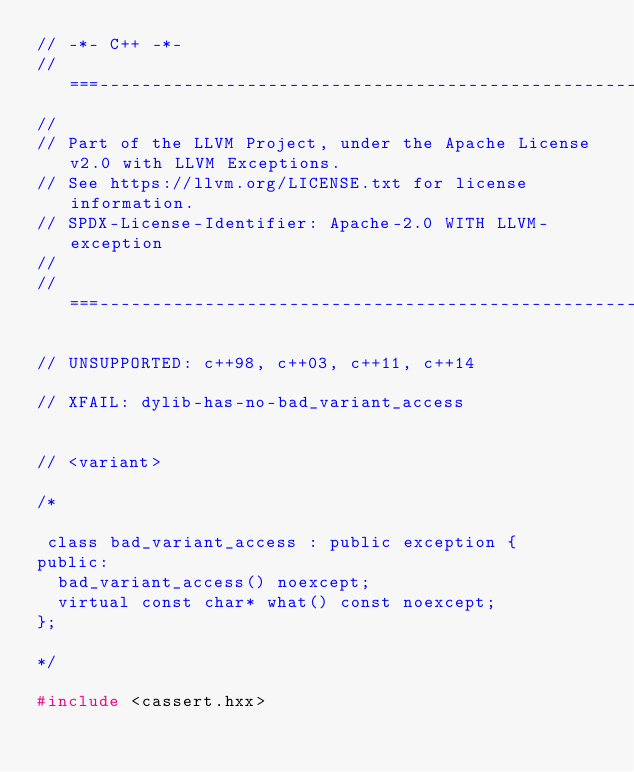<code> <loc_0><loc_0><loc_500><loc_500><_C++_>// -*- C++ -*-
//===----------------------------------------------------------------------===//
//
// Part of the LLVM Project, under the Apache License v2.0 with LLVM Exceptions.
// See https://llvm.org/LICENSE.txt for license information.
// SPDX-License-Identifier: Apache-2.0 WITH LLVM-exception
//
//===----------------------------------------------------------------------===//

// UNSUPPORTED: c++98, c++03, c++11, c++14

// XFAIL: dylib-has-no-bad_variant_access


// <variant>

/*

 class bad_variant_access : public exception {
public:
  bad_variant_access() noexcept;
  virtual const char* what() const noexcept;
};

*/

#include <cassert.hxx></code> 